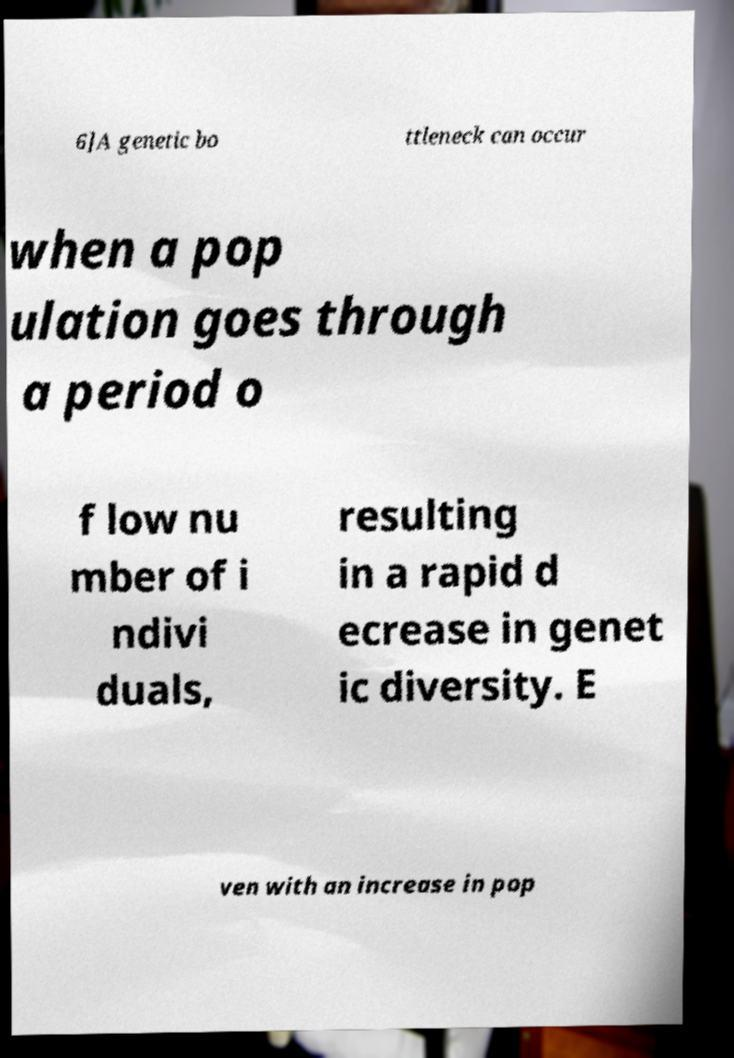There's text embedded in this image that I need extracted. Can you transcribe it verbatim? 6]A genetic bo ttleneck can occur when a pop ulation goes through a period o f low nu mber of i ndivi duals, resulting in a rapid d ecrease in genet ic diversity. E ven with an increase in pop 